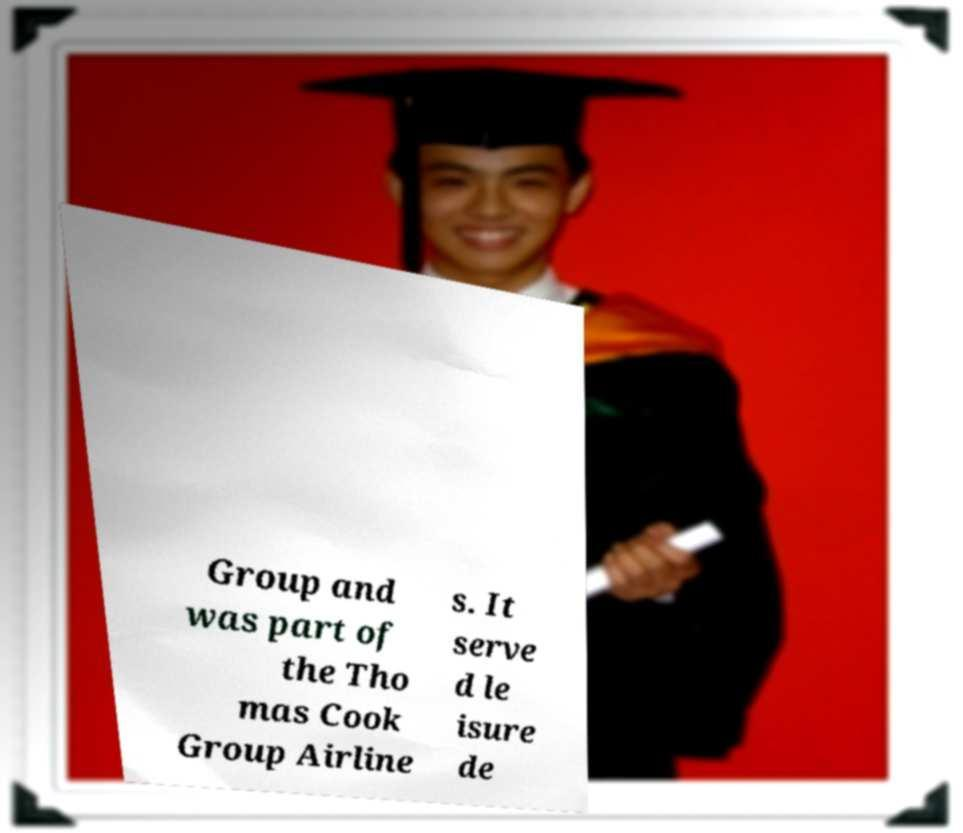Can you accurately transcribe the text from the provided image for me? Group and was part of the Tho mas Cook Group Airline s. It serve d le isure de 